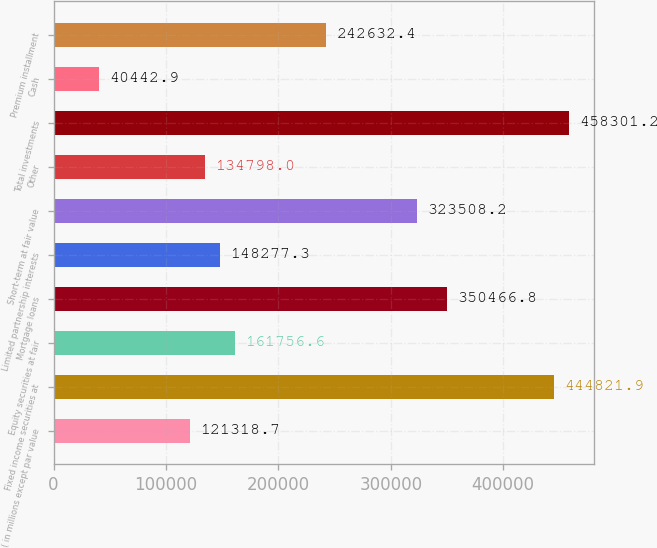Convert chart to OTSL. <chart><loc_0><loc_0><loc_500><loc_500><bar_chart><fcel>( in millions except par value<fcel>Fixed income securities at<fcel>Equity securities at fair<fcel>Mortgage loans<fcel>Limited partnership interests<fcel>Short-term at fair value<fcel>Other<fcel>Total investments<fcel>Cash<fcel>Premium installment<nl><fcel>121319<fcel>444822<fcel>161757<fcel>350467<fcel>148277<fcel>323508<fcel>134798<fcel>458301<fcel>40442.9<fcel>242632<nl></chart> 